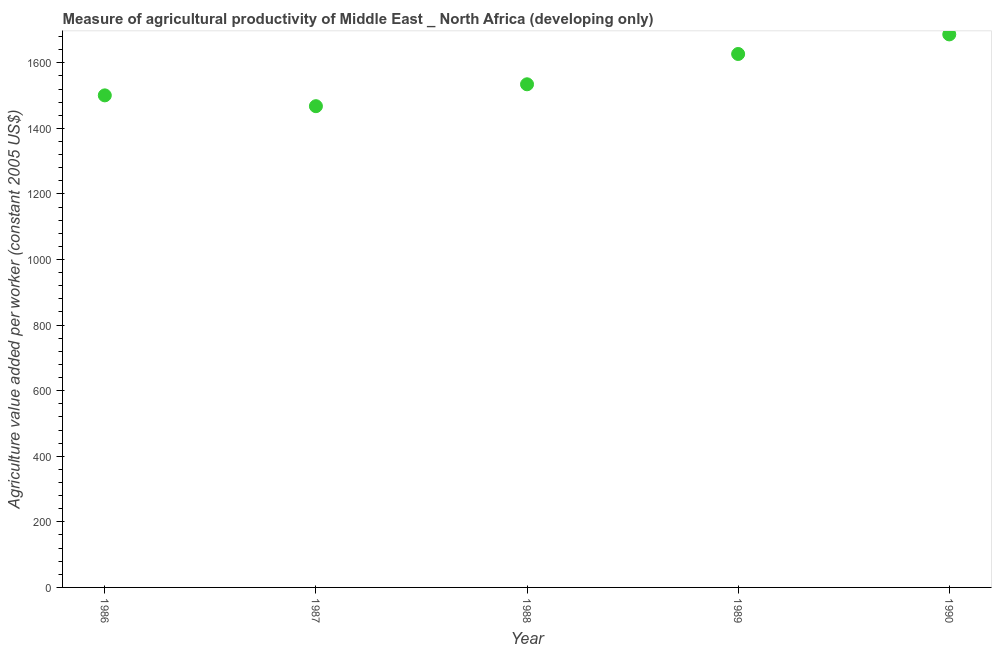What is the agriculture value added per worker in 1989?
Your response must be concise. 1626.89. Across all years, what is the maximum agriculture value added per worker?
Keep it short and to the point. 1686.59. Across all years, what is the minimum agriculture value added per worker?
Your response must be concise. 1467.72. In which year was the agriculture value added per worker minimum?
Give a very brief answer. 1987. What is the sum of the agriculture value added per worker?
Offer a terse response. 7816.33. What is the difference between the agriculture value added per worker in 1988 and 1990?
Your response must be concise. -152.13. What is the average agriculture value added per worker per year?
Your response must be concise. 1563.27. What is the median agriculture value added per worker?
Offer a very short reply. 1534.46. In how many years, is the agriculture value added per worker greater than 920 US$?
Ensure brevity in your answer.  5. Do a majority of the years between 1987 and 1988 (inclusive) have agriculture value added per worker greater than 520 US$?
Make the answer very short. Yes. What is the ratio of the agriculture value added per worker in 1988 to that in 1989?
Your answer should be very brief. 0.94. Is the agriculture value added per worker in 1988 less than that in 1989?
Provide a short and direct response. Yes. What is the difference between the highest and the second highest agriculture value added per worker?
Make the answer very short. 59.7. What is the difference between the highest and the lowest agriculture value added per worker?
Ensure brevity in your answer.  218.87. Does the agriculture value added per worker monotonically increase over the years?
Give a very brief answer. No. How many years are there in the graph?
Provide a short and direct response. 5. Does the graph contain any zero values?
Offer a very short reply. No. Does the graph contain grids?
Your answer should be compact. No. What is the title of the graph?
Provide a succinct answer. Measure of agricultural productivity of Middle East _ North Africa (developing only). What is the label or title of the Y-axis?
Offer a very short reply. Agriculture value added per worker (constant 2005 US$). What is the Agriculture value added per worker (constant 2005 US$) in 1986?
Offer a terse response. 1500.67. What is the Agriculture value added per worker (constant 2005 US$) in 1987?
Offer a very short reply. 1467.72. What is the Agriculture value added per worker (constant 2005 US$) in 1988?
Ensure brevity in your answer.  1534.46. What is the Agriculture value added per worker (constant 2005 US$) in 1989?
Provide a succinct answer. 1626.89. What is the Agriculture value added per worker (constant 2005 US$) in 1990?
Provide a succinct answer. 1686.59. What is the difference between the Agriculture value added per worker (constant 2005 US$) in 1986 and 1987?
Give a very brief answer. 32.95. What is the difference between the Agriculture value added per worker (constant 2005 US$) in 1986 and 1988?
Provide a short and direct response. -33.79. What is the difference between the Agriculture value added per worker (constant 2005 US$) in 1986 and 1989?
Your answer should be compact. -126.22. What is the difference between the Agriculture value added per worker (constant 2005 US$) in 1986 and 1990?
Provide a short and direct response. -185.92. What is the difference between the Agriculture value added per worker (constant 2005 US$) in 1987 and 1988?
Provide a short and direct response. -66.75. What is the difference between the Agriculture value added per worker (constant 2005 US$) in 1987 and 1989?
Ensure brevity in your answer.  -159.17. What is the difference between the Agriculture value added per worker (constant 2005 US$) in 1987 and 1990?
Offer a very short reply. -218.87. What is the difference between the Agriculture value added per worker (constant 2005 US$) in 1988 and 1989?
Provide a short and direct response. -92.43. What is the difference between the Agriculture value added per worker (constant 2005 US$) in 1988 and 1990?
Your response must be concise. -152.13. What is the difference between the Agriculture value added per worker (constant 2005 US$) in 1989 and 1990?
Offer a very short reply. -59.7. What is the ratio of the Agriculture value added per worker (constant 2005 US$) in 1986 to that in 1989?
Give a very brief answer. 0.92. What is the ratio of the Agriculture value added per worker (constant 2005 US$) in 1986 to that in 1990?
Provide a succinct answer. 0.89. What is the ratio of the Agriculture value added per worker (constant 2005 US$) in 1987 to that in 1988?
Give a very brief answer. 0.96. What is the ratio of the Agriculture value added per worker (constant 2005 US$) in 1987 to that in 1989?
Give a very brief answer. 0.9. What is the ratio of the Agriculture value added per worker (constant 2005 US$) in 1987 to that in 1990?
Your answer should be compact. 0.87. What is the ratio of the Agriculture value added per worker (constant 2005 US$) in 1988 to that in 1989?
Provide a succinct answer. 0.94. What is the ratio of the Agriculture value added per worker (constant 2005 US$) in 1988 to that in 1990?
Offer a terse response. 0.91. 